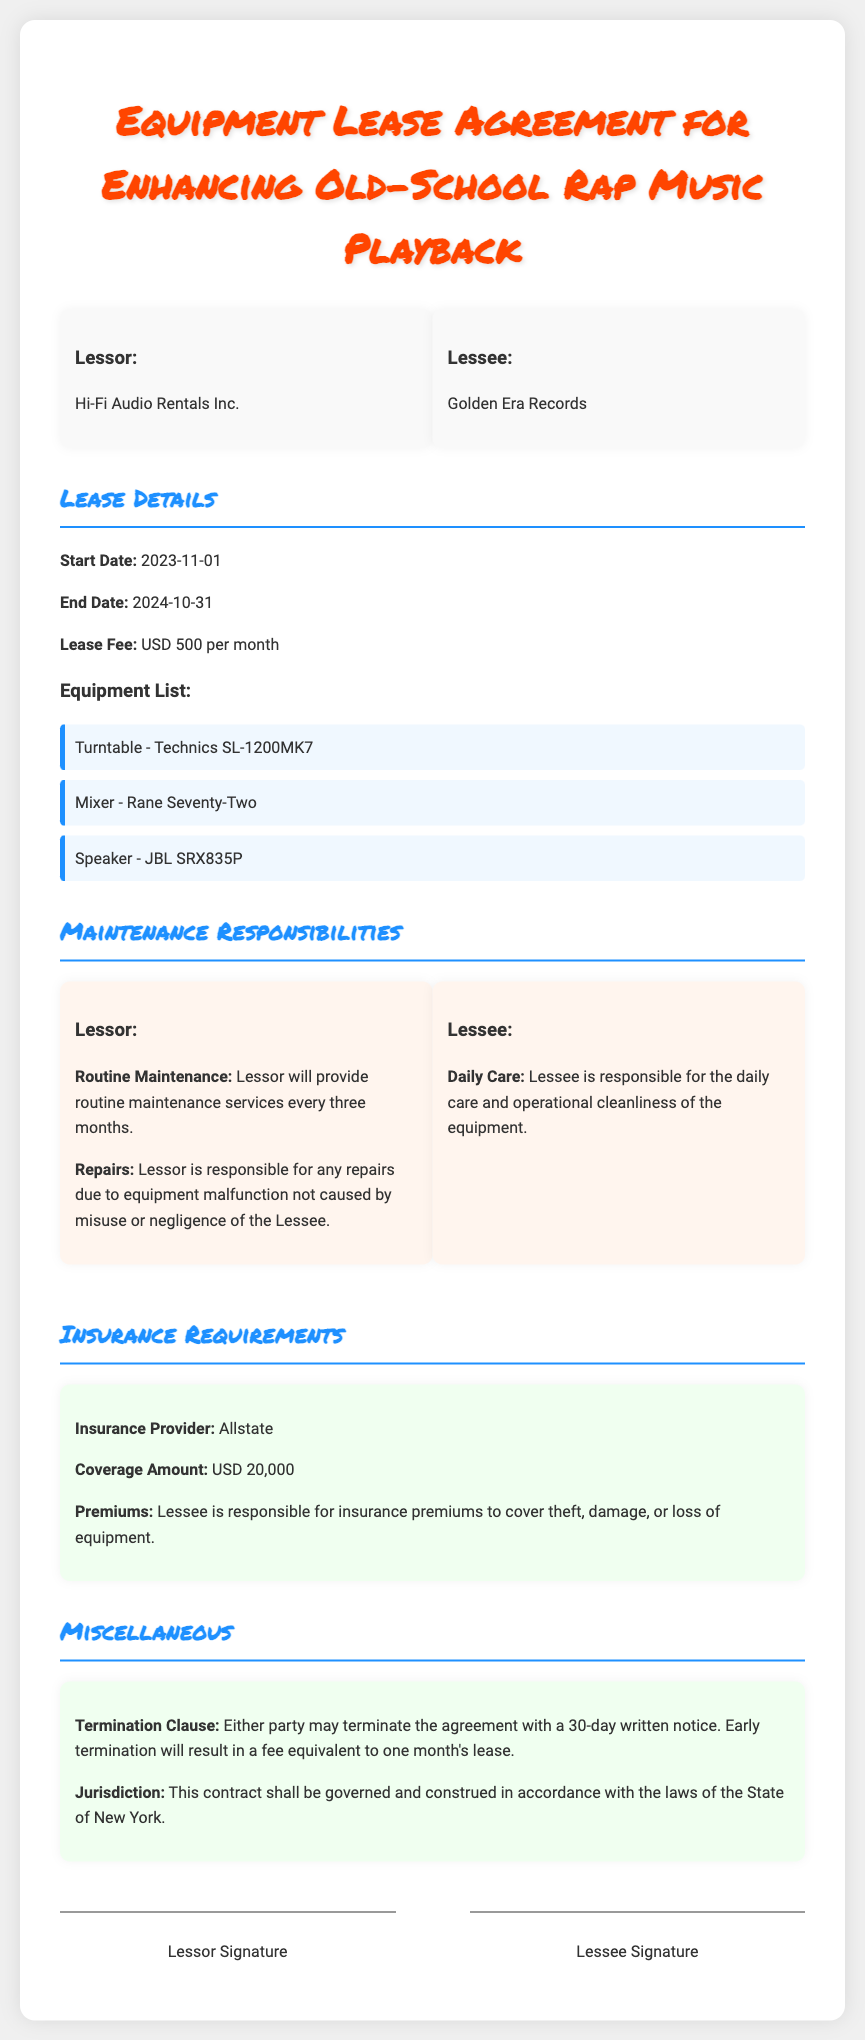What is the lease fee? The lease fee is mentioned in the contract as USD 500 per month.
Answer: USD 500 per month Who is the lessor? The lessor is identified as Hi-Fi Audio Rentals Inc. in the document.
Answer: Hi-Fi Audio Rentals Inc What is the coverage amount for the insurance? The coverage amount for the insurance is stated as USD 20,000.
Answer: USD 20,000 How often will routine maintenance be provided? The document specifies that routine maintenance will be provided every three months, indicating the frequency of maintenance.
Answer: Every three months What is the termination notice period? The contract states that either party may terminate the agreement with a 30-day written notice.
Answer: 30-day written notice What are the responsibilities of the lessee regarding the equipment? The lessee's responsibilities include daily care and operational cleanliness of the equipment.
Answer: Daily care and operational cleanliness What happens if the agreement is terminated early? The document mentions that early termination will result in a fee equivalent to one month's lease.
Answer: One month's lease Who is responsible for the insurance premiums? The responsibility for insurance premiums to cover theft, damage, or loss lies with the lessee, as detailed in the document.
Answer: Lessee What is the start date of the lease? The start date of the lease is specified in the contract as 2023-11-01.
Answer: 2023-11-01 